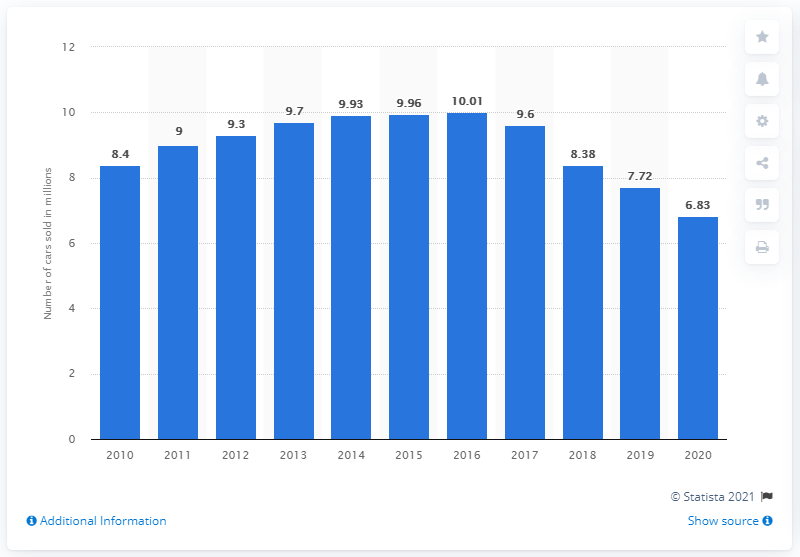Outline some significant characteristics in this image. In 2020, General Motors sold a total of 6,830 vehicles. 